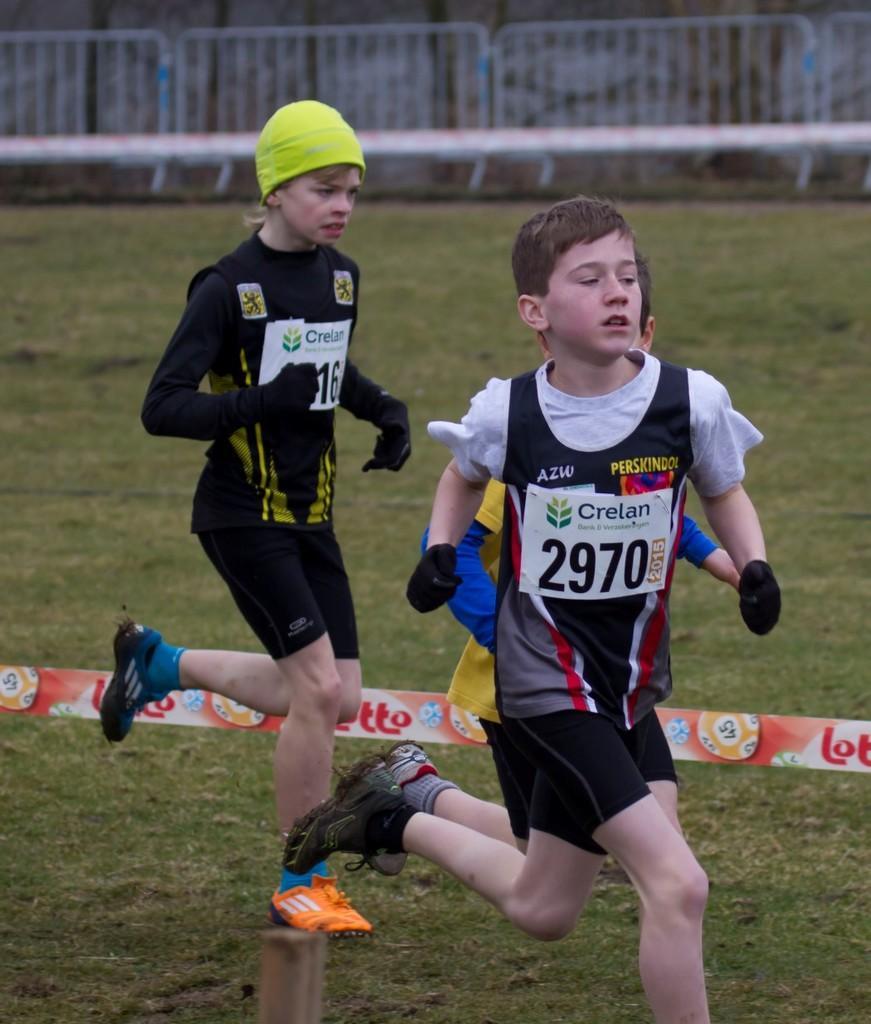Please provide a concise description of this image. In this image in the center there are kids running and there is a banner with some text written on it and there is grass on the ground. In the background there is a fence. 